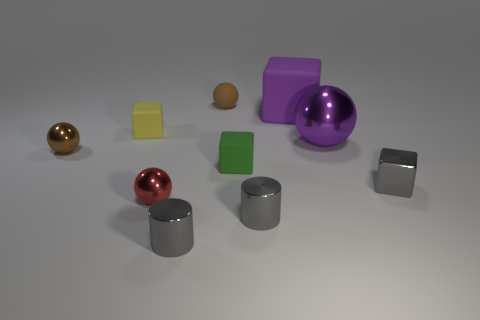Are there any tiny gray cylinders that are on the right side of the tiny brown ball behind the big purple matte cube?
Provide a succinct answer. Yes. Are there fewer matte spheres in front of the green rubber object than cubes behind the tiny gray shiny cube?
Offer a terse response. Yes. Does the brown object left of the small red object have the same material as the small sphere in front of the gray cube?
Offer a terse response. Yes. What number of tiny objects are either purple shiny spheres or gray cylinders?
Offer a very short reply. 2. There is a purple thing that is made of the same material as the small yellow block; what shape is it?
Your answer should be compact. Cube. Is the number of small matte balls that are in front of the purple matte cube less than the number of purple spheres?
Provide a succinct answer. Yes. Is the shape of the big shiny object the same as the red object?
Give a very brief answer. Yes. What number of matte things are either purple spheres or big brown objects?
Provide a short and direct response. 0. Are there any red things of the same size as the yellow block?
Offer a very short reply. Yes. What is the shape of the large thing that is the same color as the large metal sphere?
Your answer should be very brief. Cube. 